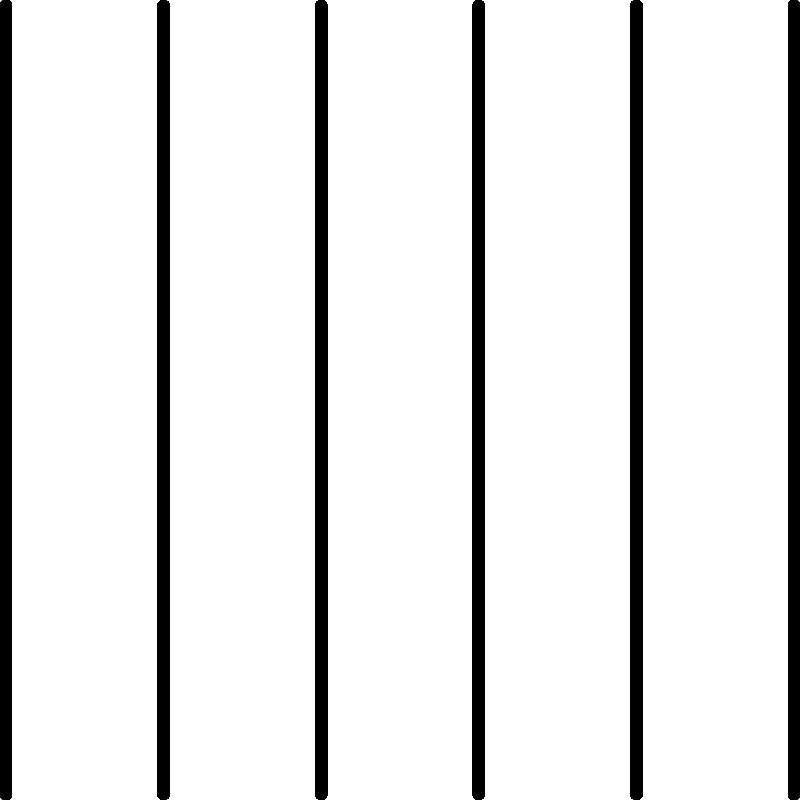As a supplier concerned with maintaining accurate product information, you need to scale a barcode image for better visibility on packaging while preserving its proportions. If the original barcode is 2 cm wide and 1 cm tall, and you want to increase its width to 3 cm, what will be the new height of the barcode? To solve this problem, we'll use the concept of scaling while maintaining proportions:

1. Identify the scale factor:
   New width / Original width = Scale factor
   $3 \text{ cm} / 2 \text{ cm} = 1.5$

2. The scale factor is 1.5, meaning all dimensions will be multiplied by 1.5.

3. Calculate the new height:
   New height = Original height × Scale factor
   New height = $1 \text{ cm} \times 1.5 = 1.5 \text{ cm}$

This scaling ensures that the barcode's proportions are maintained, which is crucial for accurate scanning and preserving product information integrity.
Answer: $1.5 \text{ cm}$ 